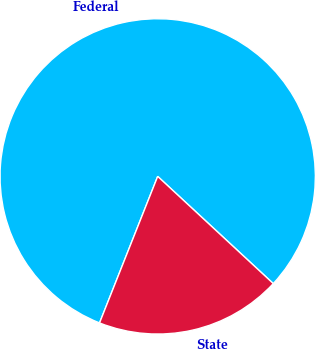Convert chart to OTSL. <chart><loc_0><loc_0><loc_500><loc_500><pie_chart><fcel>Federal<fcel>State<nl><fcel>80.89%<fcel>19.11%<nl></chart> 